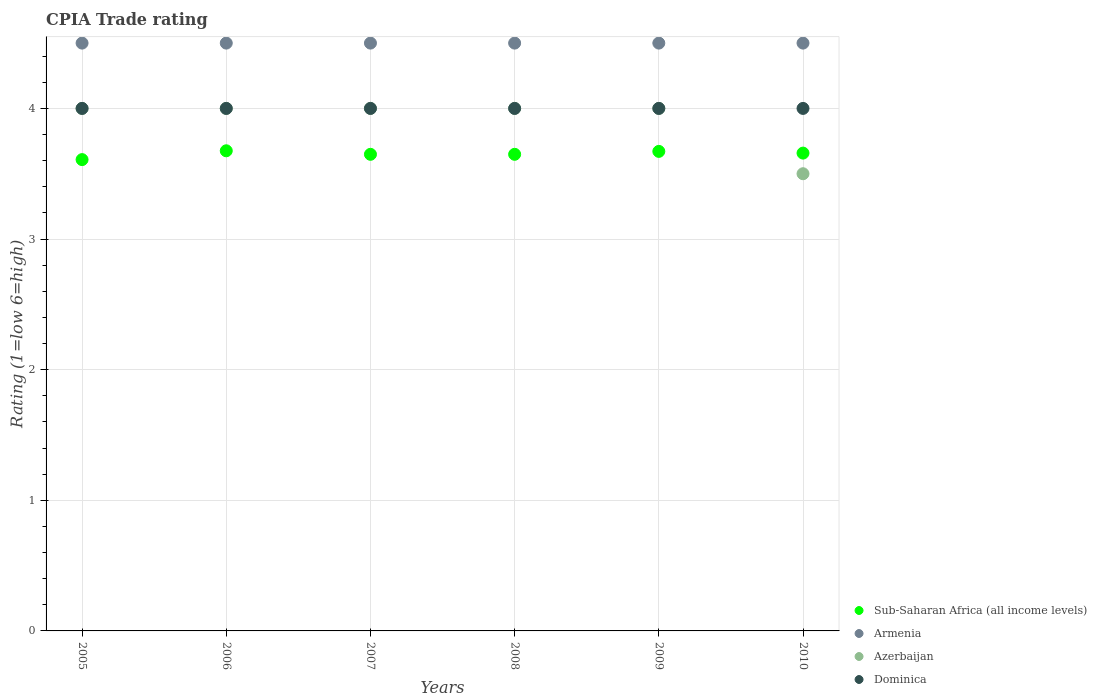Is the number of dotlines equal to the number of legend labels?
Keep it short and to the point. Yes. What is the CPIA rating in Armenia in 2010?
Offer a very short reply. 4.5. Across all years, what is the maximum CPIA rating in Azerbaijan?
Offer a very short reply. 4. Across all years, what is the minimum CPIA rating in Armenia?
Give a very brief answer. 4.5. What is the total CPIA rating in Armenia in the graph?
Provide a short and direct response. 27. What is the difference between the CPIA rating in Armenia in 2006 and that in 2008?
Offer a very short reply. 0. What is the average CPIA rating in Sub-Saharan Africa (all income levels) per year?
Your answer should be compact. 3.65. In the year 2006, what is the difference between the CPIA rating in Armenia and CPIA rating in Dominica?
Your answer should be compact. 0.5. In how many years, is the CPIA rating in Armenia greater than 3.6?
Offer a very short reply. 6. What is the ratio of the CPIA rating in Sub-Saharan Africa (all income levels) in 2007 to that in 2010?
Make the answer very short. 1. Is the CPIA rating in Sub-Saharan Africa (all income levels) in 2008 less than that in 2009?
Offer a very short reply. Yes. Is the difference between the CPIA rating in Armenia in 2006 and 2008 greater than the difference between the CPIA rating in Dominica in 2006 and 2008?
Give a very brief answer. No. What is the difference between the highest and the second highest CPIA rating in Sub-Saharan Africa (all income levels)?
Provide a short and direct response. 0. What is the difference between the highest and the lowest CPIA rating in Azerbaijan?
Make the answer very short. 0.5. Is the sum of the CPIA rating in Sub-Saharan Africa (all income levels) in 2006 and 2007 greater than the maximum CPIA rating in Dominica across all years?
Provide a short and direct response. Yes. Is it the case that in every year, the sum of the CPIA rating in Dominica and CPIA rating in Sub-Saharan Africa (all income levels)  is greater than the CPIA rating in Azerbaijan?
Ensure brevity in your answer.  Yes. Does the CPIA rating in Dominica monotonically increase over the years?
Keep it short and to the point. No. Is the CPIA rating in Armenia strictly less than the CPIA rating in Sub-Saharan Africa (all income levels) over the years?
Keep it short and to the point. No. How many dotlines are there?
Ensure brevity in your answer.  4. What is the difference between two consecutive major ticks on the Y-axis?
Your response must be concise. 1. Are the values on the major ticks of Y-axis written in scientific E-notation?
Your answer should be compact. No. Does the graph contain any zero values?
Offer a terse response. No. Where does the legend appear in the graph?
Your answer should be compact. Bottom right. How many legend labels are there?
Offer a very short reply. 4. What is the title of the graph?
Your response must be concise. CPIA Trade rating. What is the label or title of the X-axis?
Provide a succinct answer. Years. What is the label or title of the Y-axis?
Make the answer very short. Rating (1=low 6=high). What is the Rating (1=low 6=high) in Sub-Saharan Africa (all income levels) in 2005?
Provide a short and direct response. 3.61. What is the Rating (1=low 6=high) of Azerbaijan in 2005?
Ensure brevity in your answer.  4. What is the Rating (1=low 6=high) of Dominica in 2005?
Your answer should be very brief. 4. What is the Rating (1=low 6=high) of Sub-Saharan Africa (all income levels) in 2006?
Give a very brief answer. 3.68. What is the Rating (1=low 6=high) in Azerbaijan in 2006?
Ensure brevity in your answer.  4. What is the Rating (1=low 6=high) in Dominica in 2006?
Your answer should be very brief. 4. What is the Rating (1=low 6=high) in Sub-Saharan Africa (all income levels) in 2007?
Your answer should be very brief. 3.65. What is the Rating (1=low 6=high) in Sub-Saharan Africa (all income levels) in 2008?
Your answer should be compact. 3.65. What is the Rating (1=low 6=high) in Armenia in 2008?
Your answer should be compact. 4.5. What is the Rating (1=low 6=high) in Azerbaijan in 2008?
Keep it short and to the point. 4. What is the Rating (1=low 6=high) in Dominica in 2008?
Keep it short and to the point. 4. What is the Rating (1=low 6=high) of Sub-Saharan Africa (all income levels) in 2009?
Make the answer very short. 3.67. What is the Rating (1=low 6=high) in Armenia in 2009?
Your answer should be compact. 4.5. What is the Rating (1=low 6=high) of Dominica in 2009?
Offer a terse response. 4. What is the Rating (1=low 6=high) in Sub-Saharan Africa (all income levels) in 2010?
Give a very brief answer. 3.66. What is the Rating (1=low 6=high) of Armenia in 2010?
Your answer should be very brief. 4.5. What is the Rating (1=low 6=high) in Azerbaijan in 2010?
Provide a short and direct response. 3.5. What is the Rating (1=low 6=high) in Dominica in 2010?
Your answer should be very brief. 4. Across all years, what is the maximum Rating (1=low 6=high) in Sub-Saharan Africa (all income levels)?
Give a very brief answer. 3.68. Across all years, what is the minimum Rating (1=low 6=high) of Sub-Saharan Africa (all income levels)?
Provide a succinct answer. 3.61. Across all years, what is the minimum Rating (1=low 6=high) in Dominica?
Your answer should be very brief. 4. What is the total Rating (1=low 6=high) of Sub-Saharan Africa (all income levels) in the graph?
Give a very brief answer. 21.91. What is the total Rating (1=low 6=high) of Azerbaijan in the graph?
Give a very brief answer. 23.5. What is the difference between the Rating (1=low 6=high) in Sub-Saharan Africa (all income levels) in 2005 and that in 2006?
Your answer should be compact. -0.07. What is the difference between the Rating (1=low 6=high) of Armenia in 2005 and that in 2006?
Your response must be concise. 0. What is the difference between the Rating (1=low 6=high) of Dominica in 2005 and that in 2006?
Your answer should be compact. 0. What is the difference between the Rating (1=low 6=high) of Sub-Saharan Africa (all income levels) in 2005 and that in 2007?
Your answer should be compact. -0.04. What is the difference between the Rating (1=low 6=high) in Armenia in 2005 and that in 2007?
Ensure brevity in your answer.  0. What is the difference between the Rating (1=low 6=high) of Dominica in 2005 and that in 2007?
Your answer should be compact. 0. What is the difference between the Rating (1=low 6=high) of Sub-Saharan Africa (all income levels) in 2005 and that in 2008?
Your answer should be very brief. -0.04. What is the difference between the Rating (1=low 6=high) in Azerbaijan in 2005 and that in 2008?
Make the answer very short. 0. What is the difference between the Rating (1=low 6=high) in Sub-Saharan Africa (all income levels) in 2005 and that in 2009?
Offer a very short reply. -0.06. What is the difference between the Rating (1=low 6=high) in Armenia in 2005 and that in 2009?
Provide a short and direct response. 0. What is the difference between the Rating (1=low 6=high) of Dominica in 2005 and that in 2009?
Offer a terse response. 0. What is the difference between the Rating (1=low 6=high) in Sub-Saharan Africa (all income levels) in 2005 and that in 2010?
Offer a very short reply. -0.05. What is the difference between the Rating (1=low 6=high) in Azerbaijan in 2005 and that in 2010?
Keep it short and to the point. 0.5. What is the difference between the Rating (1=low 6=high) of Sub-Saharan Africa (all income levels) in 2006 and that in 2007?
Ensure brevity in your answer.  0.03. What is the difference between the Rating (1=low 6=high) of Azerbaijan in 2006 and that in 2007?
Provide a succinct answer. 0. What is the difference between the Rating (1=low 6=high) of Sub-Saharan Africa (all income levels) in 2006 and that in 2008?
Offer a terse response. 0.03. What is the difference between the Rating (1=low 6=high) of Sub-Saharan Africa (all income levels) in 2006 and that in 2009?
Ensure brevity in your answer.  0. What is the difference between the Rating (1=low 6=high) in Dominica in 2006 and that in 2009?
Your answer should be very brief. 0. What is the difference between the Rating (1=low 6=high) in Sub-Saharan Africa (all income levels) in 2006 and that in 2010?
Your answer should be compact. 0.02. What is the difference between the Rating (1=low 6=high) of Armenia in 2006 and that in 2010?
Offer a very short reply. 0. What is the difference between the Rating (1=low 6=high) in Azerbaijan in 2006 and that in 2010?
Your answer should be very brief. 0.5. What is the difference between the Rating (1=low 6=high) in Dominica in 2006 and that in 2010?
Provide a succinct answer. 0. What is the difference between the Rating (1=low 6=high) of Armenia in 2007 and that in 2008?
Offer a terse response. 0. What is the difference between the Rating (1=low 6=high) in Azerbaijan in 2007 and that in 2008?
Your response must be concise. 0. What is the difference between the Rating (1=low 6=high) in Dominica in 2007 and that in 2008?
Ensure brevity in your answer.  0. What is the difference between the Rating (1=low 6=high) in Sub-Saharan Africa (all income levels) in 2007 and that in 2009?
Ensure brevity in your answer.  -0.02. What is the difference between the Rating (1=low 6=high) in Sub-Saharan Africa (all income levels) in 2007 and that in 2010?
Your answer should be very brief. -0.01. What is the difference between the Rating (1=low 6=high) in Azerbaijan in 2007 and that in 2010?
Give a very brief answer. 0.5. What is the difference between the Rating (1=low 6=high) of Dominica in 2007 and that in 2010?
Offer a terse response. 0. What is the difference between the Rating (1=low 6=high) in Sub-Saharan Africa (all income levels) in 2008 and that in 2009?
Your response must be concise. -0.02. What is the difference between the Rating (1=low 6=high) of Dominica in 2008 and that in 2009?
Keep it short and to the point. 0. What is the difference between the Rating (1=low 6=high) of Sub-Saharan Africa (all income levels) in 2008 and that in 2010?
Your answer should be compact. -0.01. What is the difference between the Rating (1=low 6=high) in Armenia in 2008 and that in 2010?
Make the answer very short. 0. What is the difference between the Rating (1=low 6=high) in Sub-Saharan Africa (all income levels) in 2009 and that in 2010?
Your answer should be very brief. 0.01. What is the difference between the Rating (1=low 6=high) in Armenia in 2009 and that in 2010?
Give a very brief answer. 0. What is the difference between the Rating (1=low 6=high) in Azerbaijan in 2009 and that in 2010?
Offer a terse response. 0.5. What is the difference between the Rating (1=low 6=high) of Dominica in 2009 and that in 2010?
Your response must be concise. 0. What is the difference between the Rating (1=low 6=high) of Sub-Saharan Africa (all income levels) in 2005 and the Rating (1=low 6=high) of Armenia in 2006?
Offer a terse response. -0.89. What is the difference between the Rating (1=low 6=high) in Sub-Saharan Africa (all income levels) in 2005 and the Rating (1=low 6=high) in Azerbaijan in 2006?
Provide a short and direct response. -0.39. What is the difference between the Rating (1=low 6=high) in Sub-Saharan Africa (all income levels) in 2005 and the Rating (1=low 6=high) in Dominica in 2006?
Keep it short and to the point. -0.39. What is the difference between the Rating (1=low 6=high) of Armenia in 2005 and the Rating (1=low 6=high) of Azerbaijan in 2006?
Keep it short and to the point. 0.5. What is the difference between the Rating (1=low 6=high) in Armenia in 2005 and the Rating (1=low 6=high) in Dominica in 2006?
Give a very brief answer. 0.5. What is the difference between the Rating (1=low 6=high) of Sub-Saharan Africa (all income levels) in 2005 and the Rating (1=low 6=high) of Armenia in 2007?
Your response must be concise. -0.89. What is the difference between the Rating (1=low 6=high) of Sub-Saharan Africa (all income levels) in 2005 and the Rating (1=low 6=high) of Azerbaijan in 2007?
Ensure brevity in your answer.  -0.39. What is the difference between the Rating (1=low 6=high) of Sub-Saharan Africa (all income levels) in 2005 and the Rating (1=low 6=high) of Dominica in 2007?
Make the answer very short. -0.39. What is the difference between the Rating (1=low 6=high) in Armenia in 2005 and the Rating (1=low 6=high) in Dominica in 2007?
Offer a terse response. 0.5. What is the difference between the Rating (1=low 6=high) of Azerbaijan in 2005 and the Rating (1=low 6=high) of Dominica in 2007?
Offer a terse response. 0. What is the difference between the Rating (1=low 6=high) of Sub-Saharan Africa (all income levels) in 2005 and the Rating (1=low 6=high) of Armenia in 2008?
Provide a short and direct response. -0.89. What is the difference between the Rating (1=low 6=high) of Sub-Saharan Africa (all income levels) in 2005 and the Rating (1=low 6=high) of Azerbaijan in 2008?
Keep it short and to the point. -0.39. What is the difference between the Rating (1=low 6=high) of Sub-Saharan Africa (all income levels) in 2005 and the Rating (1=low 6=high) of Dominica in 2008?
Ensure brevity in your answer.  -0.39. What is the difference between the Rating (1=low 6=high) in Armenia in 2005 and the Rating (1=low 6=high) in Dominica in 2008?
Your response must be concise. 0.5. What is the difference between the Rating (1=low 6=high) in Azerbaijan in 2005 and the Rating (1=low 6=high) in Dominica in 2008?
Provide a short and direct response. 0. What is the difference between the Rating (1=low 6=high) in Sub-Saharan Africa (all income levels) in 2005 and the Rating (1=low 6=high) in Armenia in 2009?
Offer a terse response. -0.89. What is the difference between the Rating (1=low 6=high) in Sub-Saharan Africa (all income levels) in 2005 and the Rating (1=low 6=high) in Azerbaijan in 2009?
Keep it short and to the point. -0.39. What is the difference between the Rating (1=low 6=high) in Sub-Saharan Africa (all income levels) in 2005 and the Rating (1=low 6=high) in Dominica in 2009?
Your response must be concise. -0.39. What is the difference between the Rating (1=low 6=high) in Armenia in 2005 and the Rating (1=low 6=high) in Dominica in 2009?
Make the answer very short. 0.5. What is the difference between the Rating (1=low 6=high) in Azerbaijan in 2005 and the Rating (1=low 6=high) in Dominica in 2009?
Your response must be concise. 0. What is the difference between the Rating (1=low 6=high) in Sub-Saharan Africa (all income levels) in 2005 and the Rating (1=low 6=high) in Armenia in 2010?
Offer a very short reply. -0.89. What is the difference between the Rating (1=low 6=high) in Sub-Saharan Africa (all income levels) in 2005 and the Rating (1=low 6=high) in Azerbaijan in 2010?
Offer a very short reply. 0.11. What is the difference between the Rating (1=low 6=high) of Sub-Saharan Africa (all income levels) in 2005 and the Rating (1=low 6=high) of Dominica in 2010?
Give a very brief answer. -0.39. What is the difference between the Rating (1=low 6=high) of Sub-Saharan Africa (all income levels) in 2006 and the Rating (1=low 6=high) of Armenia in 2007?
Make the answer very short. -0.82. What is the difference between the Rating (1=low 6=high) of Sub-Saharan Africa (all income levels) in 2006 and the Rating (1=low 6=high) of Azerbaijan in 2007?
Offer a terse response. -0.32. What is the difference between the Rating (1=low 6=high) in Sub-Saharan Africa (all income levels) in 2006 and the Rating (1=low 6=high) in Dominica in 2007?
Keep it short and to the point. -0.32. What is the difference between the Rating (1=low 6=high) in Armenia in 2006 and the Rating (1=low 6=high) in Azerbaijan in 2007?
Your answer should be very brief. 0.5. What is the difference between the Rating (1=low 6=high) in Armenia in 2006 and the Rating (1=low 6=high) in Dominica in 2007?
Ensure brevity in your answer.  0.5. What is the difference between the Rating (1=low 6=high) of Azerbaijan in 2006 and the Rating (1=low 6=high) of Dominica in 2007?
Your response must be concise. 0. What is the difference between the Rating (1=low 6=high) of Sub-Saharan Africa (all income levels) in 2006 and the Rating (1=low 6=high) of Armenia in 2008?
Ensure brevity in your answer.  -0.82. What is the difference between the Rating (1=low 6=high) in Sub-Saharan Africa (all income levels) in 2006 and the Rating (1=low 6=high) in Azerbaijan in 2008?
Keep it short and to the point. -0.32. What is the difference between the Rating (1=low 6=high) of Sub-Saharan Africa (all income levels) in 2006 and the Rating (1=low 6=high) of Dominica in 2008?
Your answer should be very brief. -0.32. What is the difference between the Rating (1=low 6=high) in Armenia in 2006 and the Rating (1=low 6=high) in Azerbaijan in 2008?
Offer a terse response. 0.5. What is the difference between the Rating (1=low 6=high) in Azerbaijan in 2006 and the Rating (1=low 6=high) in Dominica in 2008?
Give a very brief answer. 0. What is the difference between the Rating (1=low 6=high) of Sub-Saharan Africa (all income levels) in 2006 and the Rating (1=low 6=high) of Armenia in 2009?
Give a very brief answer. -0.82. What is the difference between the Rating (1=low 6=high) in Sub-Saharan Africa (all income levels) in 2006 and the Rating (1=low 6=high) in Azerbaijan in 2009?
Your answer should be very brief. -0.32. What is the difference between the Rating (1=low 6=high) in Sub-Saharan Africa (all income levels) in 2006 and the Rating (1=low 6=high) in Dominica in 2009?
Offer a terse response. -0.32. What is the difference between the Rating (1=low 6=high) of Sub-Saharan Africa (all income levels) in 2006 and the Rating (1=low 6=high) of Armenia in 2010?
Make the answer very short. -0.82. What is the difference between the Rating (1=low 6=high) in Sub-Saharan Africa (all income levels) in 2006 and the Rating (1=low 6=high) in Azerbaijan in 2010?
Offer a very short reply. 0.18. What is the difference between the Rating (1=low 6=high) in Sub-Saharan Africa (all income levels) in 2006 and the Rating (1=low 6=high) in Dominica in 2010?
Make the answer very short. -0.32. What is the difference between the Rating (1=low 6=high) of Armenia in 2006 and the Rating (1=low 6=high) of Dominica in 2010?
Offer a terse response. 0.5. What is the difference between the Rating (1=low 6=high) of Sub-Saharan Africa (all income levels) in 2007 and the Rating (1=low 6=high) of Armenia in 2008?
Make the answer very short. -0.85. What is the difference between the Rating (1=low 6=high) in Sub-Saharan Africa (all income levels) in 2007 and the Rating (1=low 6=high) in Azerbaijan in 2008?
Keep it short and to the point. -0.35. What is the difference between the Rating (1=low 6=high) in Sub-Saharan Africa (all income levels) in 2007 and the Rating (1=low 6=high) in Dominica in 2008?
Offer a very short reply. -0.35. What is the difference between the Rating (1=low 6=high) in Armenia in 2007 and the Rating (1=low 6=high) in Azerbaijan in 2008?
Your answer should be very brief. 0.5. What is the difference between the Rating (1=low 6=high) in Armenia in 2007 and the Rating (1=low 6=high) in Dominica in 2008?
Provide a short and direct response. 0.5. What is the difference between the Rating (1=low 6=high) in Azerbaijan in 2007 and the Rating (1=low 6=high) in Dominica in 2008?
Provide a succinct answer. 0. What is the difference between the Rating (1=low 6=high) in Sub-Saharan Africa (all income levels) in 2007 and the Rating (1=low 6=high) in Armenia in 2009?
Make the answer very short. -0.85. What is the difference between the Rating (1=low 6=high) in Sub-Saharan Africa (all income levels) in 2007 and the Rating (1=low 6=high) in Azerbaijan in 2009?
Provide a short and direct response. -0.35. What is the difference between the Rating (1=low 6=high) in Sub-Saharan Africa (all income levels) in 2007 and the Rating (1=low 6=high) in Dominica in 2009?
Your answer should be very brief. -0.35. What is the difference between the Rating (1=low 6=high) of Armenia in 2007 and the Rating (1=low 6=high) of Dominica in 2009?
Offer a terse response. 0.5. What is the difference between the Rating (1=low 6=high) in Azerbaijan in 2007 and the Rating (1=low 6=high) in Dominica in 2009?
Offer a terse response. 0. What is the difference between the Rating (1=low 6=high) in Sub-Saharan Africa (all income levels) in 2007 and the Rating (1=low 6=high) in Armenia in 2010?
Your response must be concise. -0.85. What is the difference between the Rating (1=low 6=high) in Sub-Saharan Africa (all income levels) in 2007 and the Rating (1=low 6=high) in Azerbaijan in 2010?
Provide a succinct answer. 0.15. What is the difference between the Rating (1=low 6=high) in Sub-Saharan Africa (all income levels) in 2007 and the Rating (1=low 6=high) in Dominica in 2010?
Offer a very short reply. -0.35. What is the difference between the Rating (1=low 6=high) of Armenia in 2007 and the Rating (1=low 6=high) of Azerbaijan in 2010?
Offer a terse response. 1. What is the difference between the Rating (1=low 6=high) of Armenia in 2007 and the Rating (1=low 6=high) of Dominica in 2010?
Provide a succinct answer. 0.5. What is the difference between the Rating (1=low 6=high) in Sub-Saharan Africa (all income levels) in 2008 and the Rating (1=low 6=high) in Armenia in 2009?
Your answer should be very brief. -0.85. What is the difference between the Rating (1=low 6=high) of Sub-Saharan Africa (all income levels) in 2008 and the Rating (1=low 6=high) of Azerbaijan in 2009?
Your answer should be very brief. -0.35. What is the difference between the Rating (1=low 6=high) of Sub-Saharan Africa (all income levels) in 2008 and the Rating (1=low 6=high) of Dominica in 2009?
Ensure brevity in your answer.  -0.35. What is the difference between the Rating (1=low 6=high) of Azerbaijan in 2008 and the Rating (1=low 6=high) of Dominica in 2009?
Offer a very short reply. 0. What is the difference between the Rating (1=low 6=high) of Sub-Saharan Africa (all income levels) in 2008 and the Rating (1=low 6=high) of Armenia in 2010?
Provide a short and direct response. -0.85. What is the difference between the Rating (1=low 6=high) in Sub-Saharan Africa (all income levels) in 2008 and the Rating (1=low 6=high) in Azerbaijan in 2010?
Provide a succinct answer. 0.15. What is the difference between the Rating (1=low 6=high) in Sub-Saharan Africa (all income levels) in 2008 and the Rating (1=low 6=high) in Dominica in 2010?
Keep it short and to the point. -0.35. What is the difference between the Rating (1=low 6=high) in Sub-Saharan Africa (all income levels) in 2009 and the Rating (1=low 6=high) in Armenia in 2010?
Offer a very short reply. -0.83. What is the difference between the Rating (1=low 6=high) in Sub-Saharan Africa (all income levels) in 2009 and the Rating (1=low 6=high) in Azerbaijan in 2010?
Offer a terse response. 0.17. What is the difference between the Rating (1=low 6=high) in Sub-Saharan Africa (all income levels) in 2009 and the Rating (1=low 6=high) in Dominica in 2010?
Provide a succinct answer. -0.33. What is the difference between the Rating (1=low 6=high) in Armenia in 2009 and the Rating (1=low 6=high) in Dominica in 2010?
Give a very brief answer. 0.5. What is the difference between the Rating (1=low 6=high) in Azerbaijan in 2009 and the Rating (1=low 6=high) in Dominica in 2010?
Your answer should be compact. 0. What is the average Rating (1=low 6=high) of Sub-Saharan Africa (all income levels) per year?
Offer a terse response. 3.65. What is the average Rating (1=low 6=high) in Armenia per year?
Ensure brevity in your answer.  4.5. What is the average Rating (1=low 6=high) of Azerbaijan per year?
Offer a very short reply. 3.92. What is the average Rating (1=low 6=high) of Dominica per year?
Your answer should be very brief. 4. In the year 2005, what is the difference between the Rating (1=low 6=high) in Sub-Saharan Africa (all income levels) and Rating (1=low 6=high) in Armenia?
Your answer should be compact. -0.89. In the year 2005, what is the difference between the Rating (1=low 6=high) in Sub-Saharan Africa (all income levels) and Rating (1=low 6=high) in Azerbaijan?
Give a very brief answer. -0.39. In the year 2005, what is the difference between the Rating (1=low 6=high) in Sub-Saharan Africa (all income levels) and Rating (1=low 6=high) in Dominica?
Your answer should be very brief. -0.39. In the year 2005, what is the difference between the Rating (1=low 6=high) in Armenia and Rating (1=low 6=high) in Azerbaijan?
Your response must be concise. 0.5. In the year 2005, what is the difference between the Rating (1=low 6=high) of Armenia and Rating (1=low 6=high) of Dominica?
Make the answer very short. 0.5. In the year 2005, what is the difference between the Rating (1=low 6=high) of Azerbaijan and Rating (1=low 6=high) of Dominica?
Give a very brief answer. 0. In the year 2006, what is the difference between the Rating (1=low 6=high) in Sub-Saharan Africa (all income levels) and Rating (1=low 6=high) in Armenia?
Offer a terse response. -0.82. In the year 2006, what is the difference between the Rating (1=low 6=high) in Sub-Saharan Africa (all income levels) and Rating (1=low 6=high) in Azerbaijan?
Your answer should be very brief. -0.32. In the year 2006, what is the difference between the Rating (1=low 6=high) of Sub-Saharan Africa (all income levels) and Rating (1=low 6=high) of Dominica?
Keep it short and to the point. -0.32. In the year 2006, what is the difference between the Rating (1=low 6=high) in Armenia and Rating (1=low 6=high) in Azerbaijan?
Keep it short and to the point. 0.5. In the year 2006, what is the difference between the Rating (1=low 6=high) of Armenia and Rating (1=low 6=high) of Dominica?
Provide a succinct answer. 0.5. In the year 2007, what is the difference between the Rating (1=low 6=high) of Sub-Saharan Africa (all income levels) and Rating (1=low 6=high) of Armenia?
Provide a short and direct response. -0.85. In the year 2007, what is the difference between the Rating (1=low 6=high) of Sub-Saharan Africa (all income levels) and Rating (1=low 6=high) of Azerbaijan?
Your answer should be compact. -0.35. In the year 2007, what is the difference between the Rating (1=low 6=high) in Sub-Saharan Africa (all income levels) and Rating (1=low 6=high) in Dominica?
Ensure brevity in your answer.  -0.35. In the year 2007, what is the difference between the Rating (1=low 6=high) of Armenia and Rating (1=low 6=high) of Azerbaijan?
Your response must be concise. 0.5. In the year 2007, what is the difference between the Rating (1=low 6=high) of Armenia and Rating (1=low 6=high) of Dominica?
Provide a succinct answer. 0.5. In the year 2008, what is the difference between the Rating (1=low 6=high) in Sub-Saharan Africa (all income levels) and Rating (1=low 6=high) in Armenia?
Ensure brevity in your answer.  -0.85. In the year 2008, what is the difference between the Rating (1=low 6=high) of Sub-Saharan Africa (all income levels) and Rating (1=low 6=high) of Azerbaijan?
Your answer should be very brief. -0.35. In the year 2008, what is the difference between the Rating (1=low 6=high) in Sub-Saharan Africa (all income levels) and Rating (1=low 6=high) in Dominica?
Provide a short and direct response. -0.35. In the year 2008, what is the difference between the Rating (1=low 6=high) in Armenia and Rating (1=low 6=high) in Azerbaijan?
Your answer should be very brief. 0.5. In the year 2008, what is the difference between the Rating (1=low 6=high) of Azerbaijan and Rating (1=low 6=high) of Dominica?
Give a very brief answer. 0. In the year 2009, what is the difference between the Rating (1=low 6=high) of Sub-Saharan Africa (all income levels) and Rating (1=low 6=high) of Armenia?
Your answer should be very brief. -0.83. In the year 2009, what is the difference between the Rating (1=low 6=high) in Sub-Saharan Africa (all income levels) and Rating (1=low 6=high) in Azerbaijan?
Offer a terse response. -0.33. In the year 2009, what is the difference between the Rating (1=low 6=high) in Sub-Saharan Africa (all income levels) and Rating (1=low 6=high) in Dominica?
Your answer should be very brief. -0.33. In the year 2009, what is the difference between the Rating (1=low 6=high) of Armenia and Rating (1=low 6=high) of Dominica?
Your response must be concise. 0.5. In the year 2010, what is the difference between the Rating (1=low 6=high) of Sub-Saharan Africa (all income levels) and Rating (1=low 6=high) of Armenia?
Your answer should be compact. -0.84. In the year 2010, what is the difference between the Rating (1=low 6=high) of Sub-Saharan Africa (all income levels) and Rating (1=low 6=high) of Azerbaijan?
Offer a terse response. 0.16. In the year 2010, what is the difference between the Rating (1=low 6=high) in Sub-Saharan Africa (all income levels) and Rating (1=low 6=high) in Dominica?
Give a very brief answer. -0.34. In the year 2010, what is the difference between the Rating (1=low 6=high) in Armenia and Rating (1=low 6=high) in Azerbaijan?
Your answer should be very brief. 1. In the year 2010, what is the difference between the Rating (1=low 6=high) in Armenia and Rating (1=low 6=high) in Dominica?
Ensure brevity in your answer.  0.5. What is the ratio of the Rating (1=low 6=high) of Sub-Saharan Africa (all income levels) in 2005 to that in 2006?
Offer a very short reply. 0.98. What is the ratio of the Rating (1=low 6=high) in Armenia in 2005 to that in 2006?
Provide a short and direct response. 1. What is the ratio of the Rating (1=low 6=high) of Azerbaijan in 2005 to that in 2006?
Keep it short and to the point. 1. What is the ratio of the Rating (1=low 6=high) of Dominica in 2005 to that in 2006?
Keep it short and to the point. 1. What is the ratio of the Rating (1=low 6=high) of Sub-Saharan Africa (all income levels) in 2005 to that in 2007?
Ensure brevity in your answer.  0.99. What is the ratio of the Rating (1=low 6=high) of Dominica in 2005 to that in 2007?
Offer a very short reply. 1. What is the ratio of the Rating (1=low 6=high) of Sub-Saharan Africa (all income levels) in 2005 to that in 2008?
Offer a terse response. 0.99. What is the ratio of the Rating (1=low 6=high) in Azerbaijan in 2005 to that in 2008?
Your answer should be very brief. 1. What is the ratio of the Rating (1=low 6=high) in Dominica in 2005 to that in 2008?
Make the answer very short. 1. What is the ratio of the Rating (1=low 6=high) of Sub-Saharan Africa (all income levels) in 2005 to that in 2009?
Keep it short and to the point. 0.98. What is the ratio of the Rating (1=low 6=high) in Sub-Saharan Africa (all income levels) in 2005 to that in 2010?
Give a very brief answer. 0.99. What is the ratio of the Rating (1=low 6=high) of Armenia in 2005 to that in 2010?
Keep it short and to the point. 1. What is the ratio of the Rating (1=low 6=high) of Dominica in 2005 to that in 2010?
Ensure brevity in your answer.  1. What is the ratio of the Rating (1=low 6=high) in Sub-Saharan Africa (all income levels) in 2006 to that in 2007?
Ensure brevity in your answer.  1.01. What is the ratio of the Rating (1=low 6=high) of Azerbaijan in 2006 to that in 2007?
Your answer should be very brief. 1. What is the ratio of the Rating (1=low 6=high) in Sub-Saharan Africa (all income levels) in 2006 to that in 2008?
Offer a terse response. 1.01. What is the ratio of the Rating (1=low 6=high) in Sub-Saharan Africa (all income levels) in 2006 to that in 2009?
Offer a very short reply. 1. What is the ratio of the Rating (1=low 6=high) of Dominica in 2006 to that in 2009?
Offer a terse response. 1. What is the ratio of the Rating (1=low 6=high) in Sub-Saharan Africa (all income levels) in 2006 to that in 2010?
Provide a succinct answer. 1. What is the ratio of the Rating (1=low 6=high) of Azerbaijan in 2006 to that in 2010?
Make the answer very short. 1.14. What is the ratio of the Rating (1=low 6=high) of Armenia in 2007 to that in 2008?
Keep it short and to the point. 1. What is the ratio of the Rating (1=low 6=high) in Sub-Saharan Africa (all income levels) in 2007 to that in 2009?
Your answer should be compact. 0.99. What is the ratio of the Rating (1=low 6=high) in Armenia in 2007 to that in 2009?
Your answer should be compact. 1. What is the ratio of the Rating (1=low 6=high) of Sub-Saharan Africa (all income levels) in 2007 to that in 2010?
Ensure brevity in your answer.  1. What is the ratio of the Rating (1=low 6=high) of Dominica in 2007 to that in 2010?
Your response must be concise. 1. What is the ratio of the Rating (1=low 6=high) of Armenia in 2008 to that in 2010?
Your answer should be very brief. 1. What is the ratio of the Rating (1=low 6=high) of Dominica in 2008 to that in 2010?
Your response must be concise. 1. What is the ratio of the Rating (1=low 6=high) in Sub-Saharan Africa (all income levels) in 2009 to that in 2010?
Your response must be concise. 1. What is the ratio of the Rating (1=low 6=high) in Azerbaijan in 2009 to that in 2010?
Your response must be concise. 1.14. What is the ratio of the Rating (1=low 6=high) in Dominica in 2009 to that in 2010?
Offer a very short reply. 1. What is the difference between the highest and the second highest Rating (1=low 6=high) of Sub-Saharan Africa (all income levels)?
Provide a short and direct response. 0. What is the difference between the highest and the lowest Rating (1=low 6=high) of Sub-Saharan Africa (all income levels)?
Offer a very short reply. 0.07. What is the difference between the highest and the lowest Rating (1=low 6=high) in Azerbaijan?
Offer a terse response. 0.5. What is the difference between the highest and the lowest Rating (1=low 6=high) of Dominica?
Your answer should be very brief. 0. 